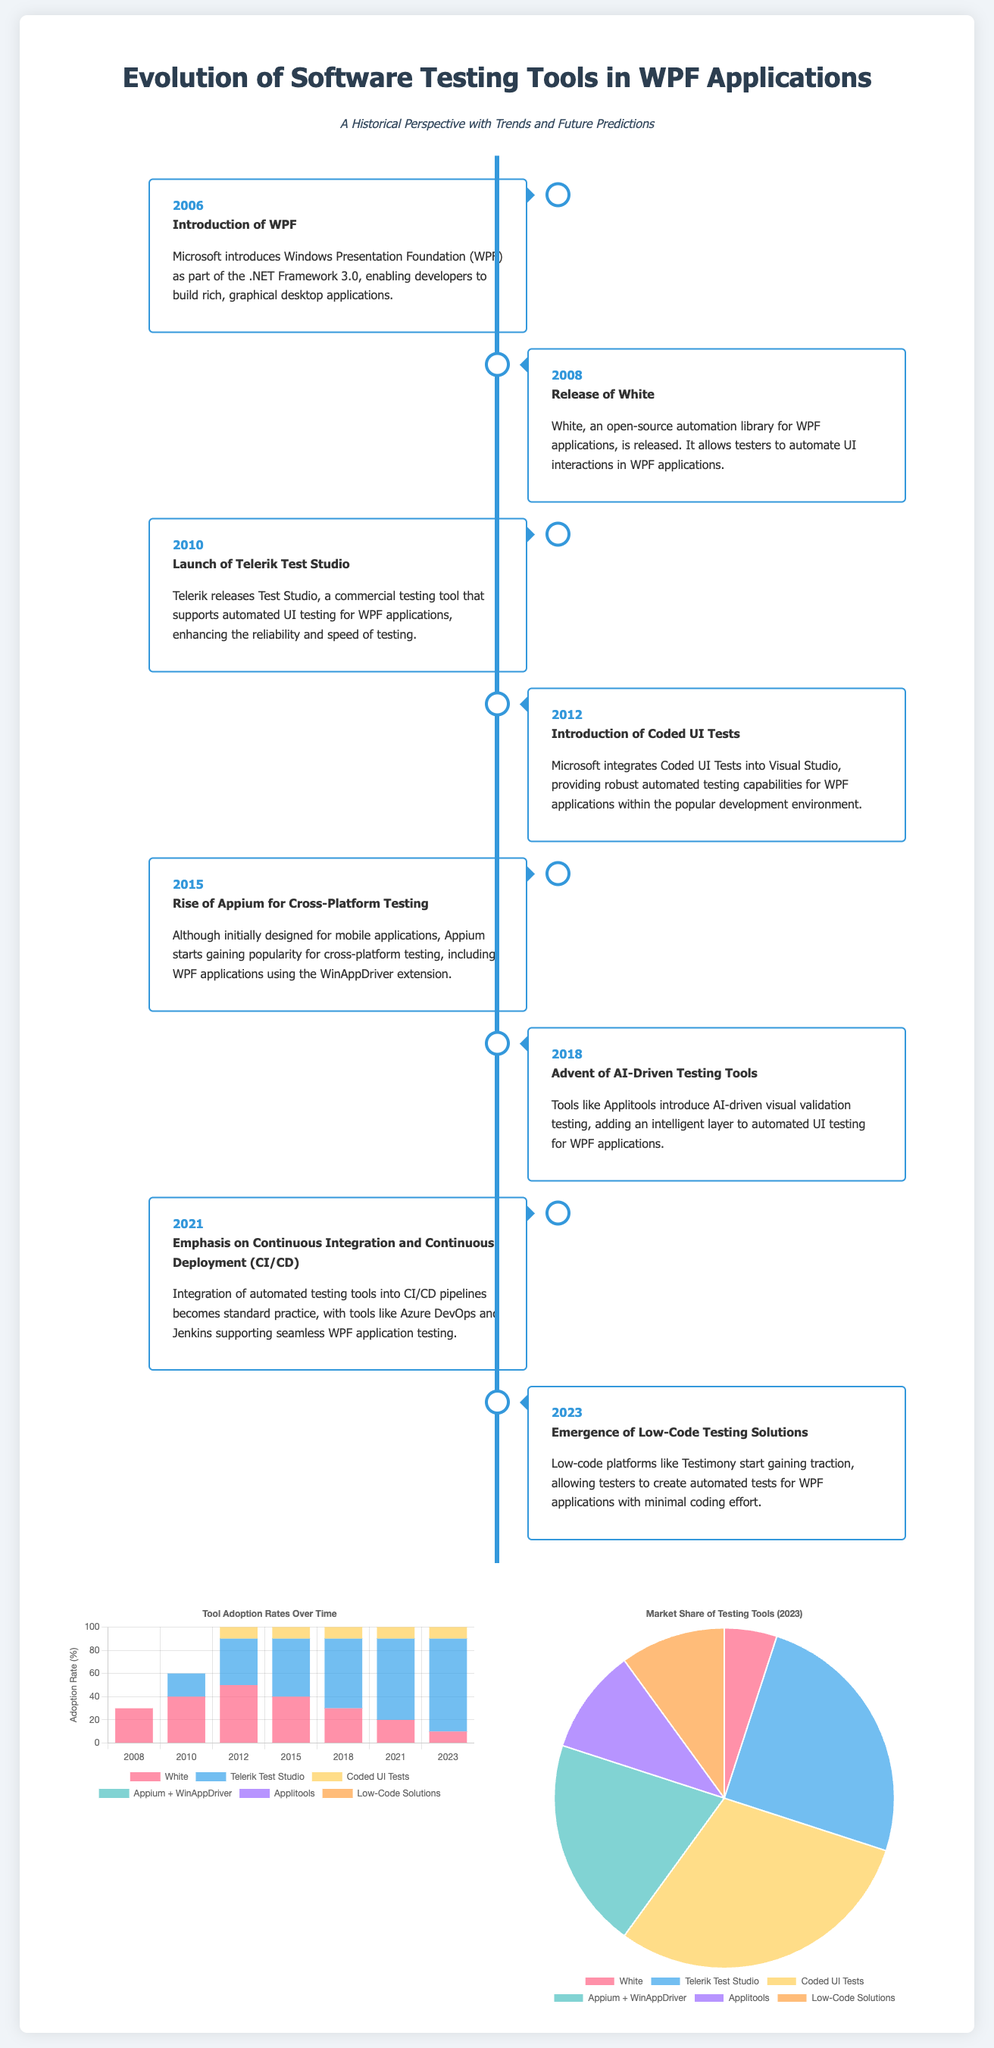What year was WPF introduced? The timeline shows the introduction of WPF in the year 2006.
Answer: 2006 Which tool was released in 2008? The timeline indicates that White, an open-source automation library, was released in 2008.
Answer: White What was the adoption rate of Coded UI Tests in 2021? The bar chart specifies that the adoption rate of Coded UI Tests in 2021 was 70 percent.
Answer: 70 Which tool had the highest market share in 2023? The pie chart shows that Telerik Test Studio had the highest market share in 2023 at 25 percent.
Answer: Telerik Test Studio What major trend started in 2021? The timeline highlights the emphasis on Continuous Integration and Continuous Deployment (CI/CD) starting in 2021.
Answer: CI/CD What is the percentage adoption rate of Low-Code Solutions in 2023? The bar chart indicates that the adoption rate of Low-Code Solutions in 2023 was 50 percent.
Answer: 50 Which tool’s adoption began in 2008? The document states that White's adoption began in 2008 as shown in the bar chart.
Answer: White What event happened in 2015 regarding testing tools? The timeline notes the rise of Appium for cross-platform testing in 2015.
Answer: Appium What feature do Low-Code Platforms like Testimony provide? The introduction in 2023 mentions that Low-Code Platforms allow minimal coding effort to create tests.
Answer: Minimal coding effort 